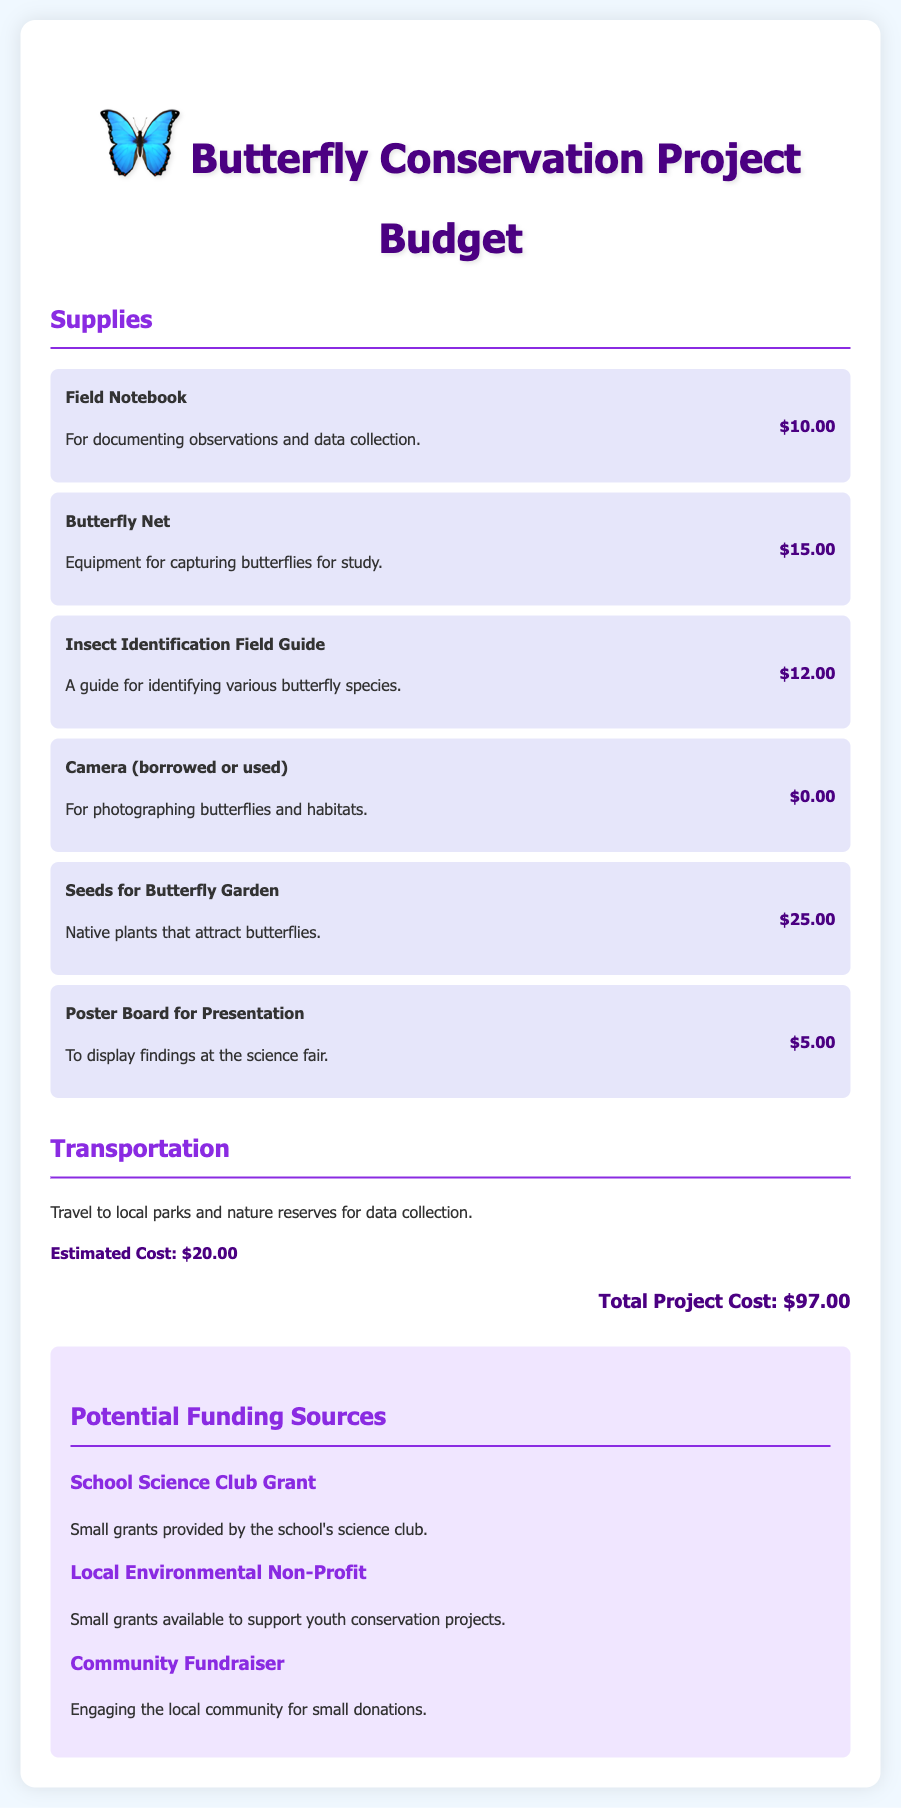what is the total project cost? The total project cost is listed at the end of the document as the sum of all expenses.
Answer: $97.00 how much does a butterfly net cost? The cost of the butterfly net is specified under supplies in the document.
Answer: $15.00 which transportation cost is estimated? The estimated transportation cost is provided for travel related to data collection.
Answer: $20.00 what is one potential funding source mentioned? The document lists several funding sources, one being the School Science Club Grant.
Answer: School Science Club Grant how many supplies are listed in the document? The supplies section contains a list of items, which can be counted directly from the list.
Answer: 6 what is the purpose of the field notebook? The document describes the purpose of the field notebook in terms of usage for the project.
Answer: Documenting observations and data collection what is the cost of seeds for the butterfly garden? The cost of seeds is detailed under supplies, specifying the price directly.
Answer: $25.00 what is the color theme of the document? The document features a specific color theme, dominant throughout the text and headings.
Answer: Purple and white 